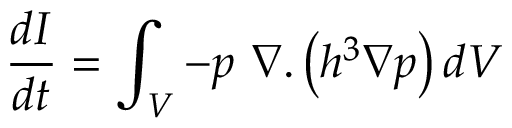Convert formula to latex. <formula><loc_0><loc_0><loc_500><loc_500>\frac { d I } { d t } = \int _ { V } - p \ \nabla . \left ( h ^ { 3 } \nabla p \right ) d V</formula> 